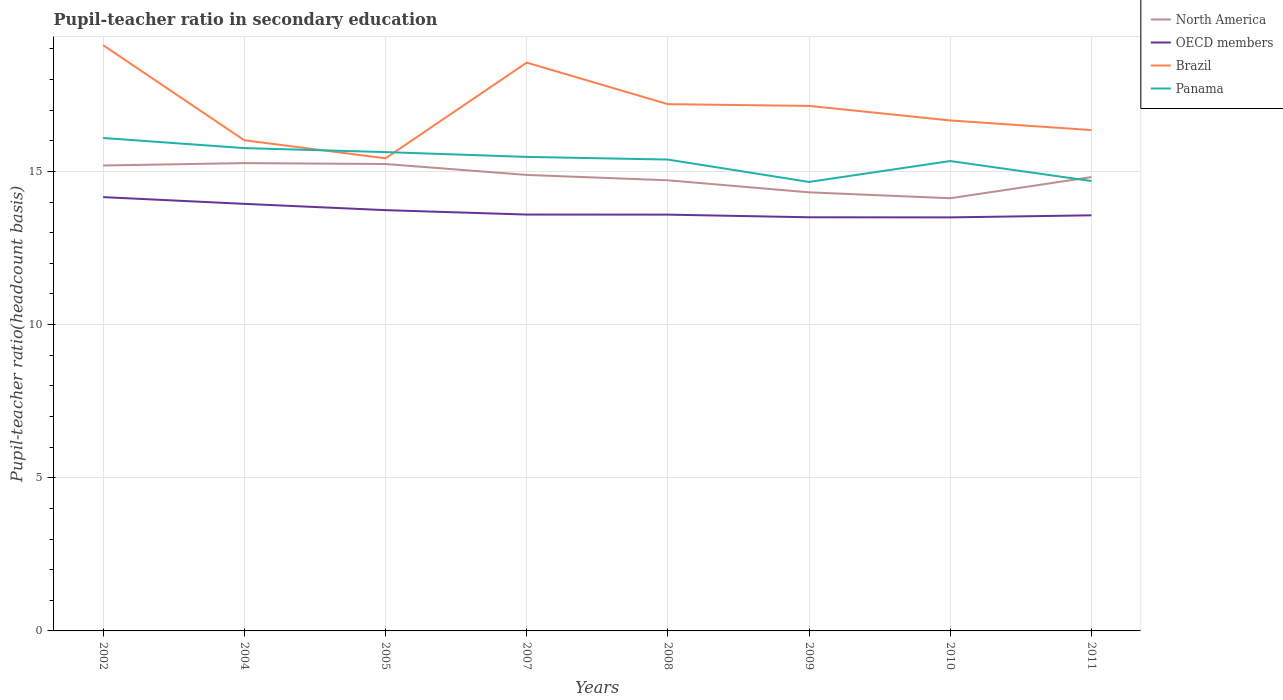How many different coloured lines are there?
Your response must be concise. 4. Across all years, what is the maximum pupil-teacher ratio in secondary education in Brazil?
Offer a terse response. 15.43. In which year was the pupil-teacher ratio in secondary education in OECD members maximum?
Your answer should be very brief. 2010. What is the total pupil-teacher ratio in secondary education in OECD members in the graph?
Your answer should be compact. -0.07. What is the difference between the highest and the second highest pupil-teacher ratio in secondary education in North America?
Ensure brevity in your answer.  1.15. What is the difference between the highest and the lowest pupil-teacher ratio in secondary education in Panama?
Keep it short and to the point. 5. Does the graph contain any zero values?
Offer a very short reply. No. Does the graph contain grids?
Keep it short and to the point. Yes. What is the title of the graph?
Your answer should be compact. Pupil-teacher ratio in secondary education. What is the label or title of the Y-axis?
Your answer should be compact. Pupil-teacher ratio(headcount basis). What is the Pupil-teacher ratio(headcount basis) of North America in 2002?
Offer a terse response. 15.19. What is the Pupil-teacher ratio(headcount basis) of OECD members in 2002?
Make the answer very short. 14.16. What is the Pupil-teacher ratio(headcount basis) in Brazil in 2002?
Offer a very short reply. 19.12. What is the Pupil-teacher ratio(headcount basis) in Panama in 2002?
Provide a short and direct response. 16.09. What is the Pupil-teacher ratio(headcount basis) in North America in 2004?
Provide a short and direct response. 15.27. What is the Pupil-teacher ratio(headcount basis) in OECD members in 2004?
Keep it short and to the point. 13.94. What is the Pupil-teacher ratio(headcount basis) in Brazil in 2004?
Your answer should be very brief. 16.02. What is the Pupil-teacher ratio(headcount basis) of Panama in 2004?
Provide a succinct answer. 15.76. What is the Pupil-teacher ratio(headcount basis) of North America in 2005?
Your answer should be very brief. 15.24. What is the Pupil-teacher ratio(headcount basis) in OECD members in 2005?
Your answer should be compact. 13.74. What is the Pupil-teacher ratio(headcount basis) in Brazil in 2005?
Make the answer very short. 15.43. What is the Pupil-teacher ratio(headcount basis) of Panama in 2005?
Make the answer very short. 15.63. What is the Pupil-teacher ratio(headcount basis) of North America in 2007?
Ensure brevity in your answer.  14.89. What is the Pupil-teacher ratio(headcount basis) of OECD members in 2007?
Your answer should be very brief. 13.59. What is the Pupil-teacher ratio(headcount basis) of Brazil in 2007?
Provide a short and direct response. 18.55. What is the Pupil-teacher ratio(headcount basis) of Panama in 2007?
Your response must be concise. 15.47. What is the Pupil-teacher ratio(headcount basis) in North America in 2008?
Ensure brevity in your answer.  14.71. What is the Pupil-teacher ratio(headcount basis) in OECD members in 2008?
Provide a short and direct response. 13.59. What is the Pupil-teacher ratio(headcount basis) of Brazil in 2008?
Provide a succinct answer. 17.2. What is the Pupil-teacher ratio(headcount basis) in Panama in 2008?
Provide a short and direct response. 15.39. What is the Pupil-teacher ratio(headcount basis) in North America in 2009?
Give a very brief answer. 14.32. What is the Pupil-teacher ratio(headcount basis) of OECD members in 2009?
Ensure brevity in your answer.  13.5. What is the Pupil-teacher ratio(headcount basis) of Brazil in 2009?
Your answer should be very brief. 17.14. What is the Pupil-teacher ratio(headcount basis) in Panama in 2009?
Offer a very short reply. 14.66. What is the Pupil-teacher ratio(headcount basis) of North America in 2010?
Ensure brevity in your answer.  14.12. What is the Pupil-teacher ratio(headcount basis) in OECD members in 2010?
Your answer should be compact. 13.5. What is the Pupil-teacher ratio(headcount basis) of Brazil in 2010?
Give a very brief answer. 16.66. What is the Pupil-teacher ratio(headcount basis) in Panama in 2010?
Make the answer very short. 15.34. What is the Pupil-teacher ratio(headcount basis) in North America in 2011?
Provide a succinct answer. 14.81. What is the Pupil-teacher ratio(headcount basis) in OECD members in 2011?
Provide a short and direct response. 13.57. What is the Pupil-teacher ratio(headcount basis) in Brazil in 2011?
Keep it short and to the point. 16.35. What is the Pupil-teacher ratio(headcount basis) in Panama in 2011?
Give a very brief answer. 14.69. Across all years, what is the maximum Pupil-teacher ratio(headcount basis) of North America?
Keep it short and to the point. 15.27. Across all years, what is the maximum Pupil-teacher ratio(headcount basis) of OECD members?
Offer a very short reply. 14.16. Across all years, what is the maximum Pupil-teacher ratio(headcount basis) in Brazil?
Your answer should be very brief. 19.12. Across all years, what is the maximum Pupil-teacher ratio(headcount basis) of Panama?
Your answer should be compact. 16.09. Across all years, what is the minimum Pupil-teacher ratio(headcount basis) of North America?
Make the answer very short. 14.12. Across all years, what is the minimum Pupil-teacher ratio(headcount basis) in OECD members?
Offer a terse response. 13.5. Across all years, what is the minimum Pupil-teacher ratio(headcount basis) of Brazil?
Offer a terse response. 15.43. Across all years, what is the minimum Pupil-teacher ratio(headcount basis) in Panama?
Make the answer very short. 14.66. What is the total Pupil-teacher ratio(headcount basis) of North America in the graph?
Make the answer very short. 118.56. What is the total Pupil-teacher ratio(headcount basis) in OECD members in the graph?
Ensure brevity in your answer.  109.59. What is the total Pupil-teacher ratio(headcount basis) in Brazil in the graph?
Provide a succinct answer. 136.46. What is the total Pupil-teacher ratio(headcount basis) in Panama in the graph?
Ensure brevity in your answer.  123.03. What is the difference between the Pupil-teacher ratio(headcount basis) of North America in 2002 and that in 2004?
Keep it short and to the point. -0.08. What is the difference between the Pupil-teacher ratio(headcount basis) of OECD members in 2002 and that in 2004?
Give a very brief answer. 0.22. What is the difference between the Pupil-teacher ratio(headcount basis) of Brazil in 2002 and that in 2004?
Provide a succinct answer. 3.1. What is the difference between the Pupil-teacher ratio(headcount basis) in Panama in 2002 and that in 2004?
Your answer should be very brief. 0.33. What is the difference between the Pupil-teacher ratio(headcount basis) of North America in 2002 and that in 2005?
Provide a short and direct response. -0.05. What is the difference between the Pupil-teacher ratio(headcount basis) in OECD members in 2002 and that in 2005?
Give a very brief answer. 0.42. What is the difference between the Pupil-teacher ratio(headcount basis) in Brazil in 2002 and that in 2005?
Keep it short and to the point. 3.69. What is the difference between the Pupil-teacher ratio(headcount basis) in Panama in 2002 and that in 2005?
Make the answer very short. 0.46. What is the difference between the Pupil-teacher ratio(headcount basis) in North America in 2002 and that in 2007?
Provide a succinct answer. 0.31. What is the difference between the Pupil-teacher ratio(headcount basis) in OECD members in 2002 and that in 2007?
Your answer should be very brief. 0.57. What is the difference between the Pupil-teacher ratio(headcount basis) of Brazil in 2002 and that in 2007?
Your answer should be compact. 0.57. What is the difference between the Pupil-teacher ratio(headcount basis) of Panama in 2002 and that in 2007?
Ensure brevity in your answer.  0.62. What is the difference between the Pupil-teacher ratio(headcount basis) of North America in 2002 and that in 2008?
Provide a succinct answer. 0.48. What is the difference between the Pupil-teacher ratio(headcount basis) in OECD members in 2002 and that in 2008?
Give a very brief answer. 0.57. What is the difference between the Pupil-teacher ratio(headcount basis) of Brazil in 2002 and that in 2008?
Your response must be concise. 1.93. What is the difference between the Pupil-teacher ratio(headcount basis) in Panama in 2002 and that in 2008?
Offer a very short reply. 0.7. What is the difference between the Pupil-teacher ratio(headcount basis) of North America in 2002 and that in 2009?
Offer a very short reply. 0.88. What is the difference between the Pupil-teacher ratio(headcount basis) in OECD members in 2002 and that in 2009?
Your answer should be compact. 0.66. What is the difference between the Pupil-teacher ratio(headcount basis) in Brazil in 2002 and that in 2009?
Provide a short and direct response. 1.98. What is the difference between the Pupil-teacher ratio(headcount basis) of Panama in 2002 and that in 2009?
Your response must be concise. 1.43. What is the difference between the Pupil-teacher ratio(headcount basis) of North America in 2002 and that in 2010?
Make the answer very short. 1.07. What is the difference between the Pupil-teacher ratio(headcount basis) in OECD members in 2002 and that in 2010?
Your answer should be compact. 0.66. What is the difference between the Pupil-teacher ratio(headcount basis) in Brazil in 2002 and that in 2010?
Keep it short and to the point. 2.46. What is the difference between the Pupil-teacher ratio(headcount basis) of Panama in 2002 and that in 2010?
Give a very brief answer. 0.75. What is the difference between the Pupil-teacher ratio(headcount basis) in North America in 2002 and that in 2011?
Provide a succinct answer. 0.38. What is the difference between the Pupil-teacher ratio(headcount basis) of OECD members in 2002 and that in 2011?
Offer a terse response. 0.59. What is the difference between the Pupil-teacher ratio(headcount basis) in Brazil in 2002 and that in 2011?
Give a very brief answer. 2.77. What is the difference between the Pupil-teacher ratio(headcount basis) of Panama in 2002 and that in 2011?
Keep it short and to the point. 1.4. What is the difference between the Pupil-teacher ratio(headcount basis) of North America in 2004 and that in 2005?
Your response must be concise. 0.03. What is the difference between the Pupil-teacher ratio(headcount basis) of OECD members in 2004 and that in 2005?
Provide a short and direct response. 0.21. What is the difference between the Pupil-teacher ratio(headcount basis) of Brazil in 2004 and that in 2005?
Offer a terse response. 0.59. What is the difference between the Pupil-teacher ratio(headcount basis) in Panama in 2004 and that in 2005?
Make the answer very short. 0.13. What is the difference between the Pupil-teacher ratio(headcount basis) of North America in 2004 and that in 2007?
Provide a short and direct response. 0.39. What is the difference between the Pupil-teacher ratio(headcount basis) of OECD members in 2004 and that in 2007?
Offer a very short reply. 0.35. What is the difference between the Pupil-teacher ratio(headcount basis) in Brazil in 2004 and that in 2007?
Your response must be concise. -2.53. What is the difference between the Pupil-teacher ratio(headcount basis) of Panama in 2004 and that in 2007?
Your answer should be very brief. 0.29. What is the difference between the Pupil-teacher ratio(headcount basis) in North America in 2004 and that in 2008?
Ensure brevity in your answer.  0.56. What is the difference between the Pupil-teacher ratio(headcount basis) in OECD members in 2004 and that in 2008?
Your response must be concise. 0.35. What is the difference between the Pupil-teacher ratio(headcount basis) in Brazil in 2004 and that in 2008?
Offer a terse response. -1.18. What is the difference between the Pupil-teacher ratio(headcount basis) of Panama in 2004 and that in 2008?
Offer a terse response. 0.37. What is the difference between the Pupil-teacher ratio(headcount basis) of North America in 2004 and that in 2009?
Ensure brevity in your answer.  0.95. What is the difference between the Pupil-teacher ratio(headcount basis) in OECD members in 2004 and that in 2009?
Provide a succinct answer. 0.44. What is the difference between the Pupil-teacher ratio(headcount basis) in Brazil in 2004 and that in 2009?
Keep it short and to the point. -1.12. What is the difference between the Pupil-teacher ratio(headcount basis) in Panama in 2004 and that in 2009?
Provide a short and direct response. 1.1. What is the difference between the Pupil-teacher ratio(headcount basis) in North America in 2004 and that in 2010?
Your answer should be very brief. 1.15. What is the difference between the Pupil-teacher ratio(headcount basis) of OECD members in 2004 and that in 2010?
Provide a succinct answer. 0.44. What is the difference between the Pupil-teacher ratio(headcount basis) in Brazil in 2004 and that in 2010?
Offer a very short reply. -0.65. What is the difference between the Pupil-teacher ratio(headcount basis) in Panama in 2004 and that in 2010?
Offer a very short reply. 0.42. What is the difference between the Pupil-teacher ratio(headcount basis) in North America in 2004 and that in 2011?
Provide a short and direct response. 0.46. What is the difference between the Pupil-teacher ratio(headcount basis) in OECD members in 2004 and that in 2011?
Keep it short and to the point. 0.37. What is the difference between the Pupil-teacher ratio(headcount basis) of Brazil in 2004 and that in 2011?
Provide a succinct answer. -0.33. What is the difference between the Pupil-teacher ratio(headcount basis) in Panama in 2004 and that in 2011?
Ensure brevity in your answer.  1.07. What is the difference between the Pupil-teacher ratio(headcount basis) in North America in 2005 and that in 2007?
Offer a very short reply. 0.36. What is the difference between the Pupil-teacher ratio(headcount basis) in OECD members in 2005 and that in 2007?
Offer a terse response. 0.14. What is the difference between the Pupil-teacher ratio(headcount basis) of Brazil in 2005 and that in 2007?
Your response must be concise. -3.12. What is the difference between the Pupil-teacher ratio(headcount basis) in Panama in 2005 and that in 2007?
Provide a short and direct response. 0.16. What is the difference between the Pupil-teacher ratio(headcount basis) in North America in 2005 and that in 2008?
Give a very brief answer. 0.53. What is the difference between the Pupil-teacher ratio(headcount basis) of OECD members in 2005 and that in 2008?
Your answer should be compact. 0.15. What is the difference between the Pupil-teacher ratio(headcount basis) in Brazil in 2005 and that in 2008?
Your answer should be very brief. -1.77. What is the difference between the Pupil-teacher ratio(headcount basis) of Panama in 2005 and that in 2008?
Offer a very short reply. 0.24. What is the difference between the Pupil-teacher ratio(headcount basis) in North America in 2005 and that in 2009?
Your answer should be compact. 0.92. What is the difference between the Pupil-teacher ratio(headcount basis) in OECD members in 2005 and that in 2009?
Your response must be concise. 0.23. What is the difference between the Pupil-teacher ratio(headcount basis) in Brazil in 2005 and that in 2009?
Ensure brevity in your answer.  -1.71. What is the difference between the Pupil-teacher ratio(headcount basis) in Panama in 2005 and that in 2009?
Your answer should be very brief. 0.97. What is the difference between the Pupil-teacher ratio(headcount basis) of North America in 2005 and that in 2010?
Offer a terse response. 1.12. What is the difference between the Pupil-teacher ratio(headcount basis) of OECD members in 2005 and that in 2010?
Keep it short and to the point. 0.24. What is the difference between the Pupil-teacher ratio(headcount basis) of Brazil in 2005 and that in 2010?
Provide a short and direct response. -1.24. What is the difference between the Pupil-teacher ratio(headcount basis) in Panama in 2005 and that in 2010?
Make the answer very short. 0.29. What is the difference between the Pupil-teacher ratio(headcount basis) of North America in 2005 and that in 2011?
Make the answer very short. 0.43. What is the difference between the Pupil-teacher ratio(headcount basis) of OECD members in 2005 and that in 2011?
Your answer should be very brief. 0.17. What is the difference between the Pupil-teacher ratio(headcount basis) of Brazil in 2005 and that in 2011?
Offer a very short reply. -0.92. What is the difference between the Pupil-teacher ratio(headcount basis) in Panama in 2005 and that in 2011?
Your answer should be very brief. 0.94. What is the difference between the Pupil-teacher ratio(headcount basis) in North America in 2007 and that in 2008?
Provide a short and direct response. 0.18. What is the difference between the Pupil-teacher ratio(headcount basis) in OECD members in 2007 and that in 2008?
Keep it short and to the point. 0. What is the difference between the Pupil-teacher ratio(headcount basis) in Brazil in 2007 and that in 2008?
Ensure brevity in your answer.  1.36. What is the difference between the Pupil-teacher ratio(headcount basis) of Panama in 2007 and that in 2008?
Offer a terse response. 0.09. What is the difference between the Pupil-teacher ratio(headcount basis) in North America in 2007 and that in 2009?
Your answer should be compact. 0.57. What is the difference between the Pupil-teacher ratio(headcount basis) in OECD members in 2007 and that in 2009?
Provide a succinct answer. 0.09. What is the difference between the Pupil-teacher ratio(headcount basis) of Brazil in 2007 and that in 2009?
Provide a short and direct response. 1.41. What is the difference between the Pupil-teacher ratio(headcount basis) in Panama in 2007 and that in 2009?
Your response must be concise. 0.82. What is the difference between the Pupil-teacher ratio(headcount basis) in North America in 2007 and that in 2010?
Provide a short and direct response. 0.76. What is the difference between the Pupil-teacher ratio(headcount basis) in OECD members in 2007 and that in 2010?
Keep it short and to the point. 0.09. What is the difference between the Pupil-teacher ratio(headcount basis) in Brazil in 2007 and that in 2010?
Give a very brief answer. 1.89. What is the difference between the Pupil-teacher ratio(headcount basis) of Panama in 2007 and that in 2010?
Your answer should be compact. 0.14. What is the difference between the Pupil-teacher ratio(headcount basis) of North America in 2007 and that in 2011?
Keep it short and to the point. 0.07. What is the difference between the Pupil-teacher ratio(headcount basis) in OECD members in 2007 and that in 2011?
Offer a terse response. 0.02. What is the difference between the Pupil-teacher ratio(headcount basis) in Brazil in 2007 and that in 2011?
Provide a short and direct response. 2.2. What is the difference between the Pupil-teacher ratio(headcount basis) of Panama in 2007 and that in 2011?
Offer a very short reply. 0.79. What is the difference between the Pupil-teacher ratio(headcount basis) of North America in 2008 and that in 2009?
Your answer should be very brief. 0.39. What is the difference between the Pupil-teacher ratio(headcount basis) of OECD members in 2008 and that in 2009?
Your answer should be very brief. 0.09. What is the difference between the Pupil-teacher ratio(headcount basis) in Brazil in 2008 and that in 2009?
Your answer should be very brief. 0.06. What is the difference between the Pupil-teacher ratio(headcount basis) of Panama in 2008 and that in 2009?
Your answer should be very brief. 0.73. What is the difference between the Pupil-teacher ratio(headcount basis) of North America in 2008 and that in 2010?
Provide a succinct answer. 0.59. What is the difference between the Pupil-teacher ratio(headcount basis) of OECD members in 2008 and that in 2010?
Provide a short and direct response. 0.09. What is the difference between the Pupil-teacher ratio(headcount basis) of Brazil in 2008 and that in 2010?
Your answer should be very brief. 0.53. What is the difference between the Pupil-teacher ratio(headcount basis) of Panama in 2008 and that in 2010?
Your response must be concise. 0.05. What is the difference between the Pupil-teacher ratio(headcount basis) in North America in 2008 and that in 2011?
Your answer should be very brief. -0.1. What is the difference between the Pupil-teacher ratio(headcount basis) in OECD members in 2008 and that in 2011?
Keep it short and to the point. 0.02. What is the difference between the Pupil-teacher ratio(headcount basis) of Brazil in 2008 and that in 2011?
Make the answer very short. 0.85. What is the difference between the Pupil-teacher ratio(headcount basis) in Panama in 2008 and that in 2011?
Your response must be concise. 0.7. What is the difference between the Pupil-teacher ratio(headcount basis) of North America in 2009 and that in 2010?
Your answer should be very brief. 0.19. What is the difference between the Pupil-teacher ratio(headcount basis) of OECD members in 2009 and that in 2010?
Your response must be concise. 0. What is the difference between the Pupil-teacher ratio(headcount basis) in Brazil in 2009 and that in 2010?
Offer a very short reply. 0.47. What is the difference between the Pupil-teacher ratio(headcount basis) in Panama in 2009 and that in 2010?
Provide a succinct answer. -0.68. What is the difference between the Pupil-teacher ratio(headcount basis) of North America in 2009 and that in 2011?
Make the answer very short. -0.5. What is the difference between the Pupil-teacher ratio(headcount basis) of OECD members in 2009 and that in 2011?
Provide a short and direct response. -0.06. What is the difference between the Pupil-teacher ratio(headcount basis) in Brazil in 2009 and that in 2011?
Make the answer very short. 0.79. What is the difference between the Pupil-teacher ratio(headcount basis) of Panama in 2009 and that in 2011?
Your answer should be very brief. -0.03. What is the difference between the Pupil-teacher ratio(headcount basis) in North America in 2010 and that in 2011?
Keep it short and to the point. -0.69. What is the difference between the Pupil-teacher ratio(headcount basis) of OECD members in 2010 and that in 2011?
Keep it short and to the point. -0.07. What is the difference between the Pupil-teacher ratio(headcount basis) of Brazil in 2010 and that in 2011?
Offer a terse response. 0.31. What is the difference between the Pupil-teacher ratio(headcount basis) of Panama in 2010 and that in 2011?
Offer a very short reply. 0.65. What is the difference between the Pupil-teacher ratio(headcount basis) in North America in 2002 and the Pupil-teacher ratio(headcount basis) in OECD members in 2004?
Provide a succinct answer. 1.25. What is the difference between the Pupil-teacher ratio(headcount basis) of North America in 2002 and the Pupil-teacher ratio(headcount basis) of Brazil in 2004?
Your answer should be compact. -0.82. What is the difference between the Pupil-teacher ratio(headcount basis) in North America in 2002 and the Pupil-teacher ratio(headcount basis) in Panama in 2004?
Your answer should be very brief. -0.57. What is the difference between the Pupil-teacher ratio(headcount basis) of OECD members in 2002 and the Pupil-teacher ratio(headcount basis) of Brazil in 2004?
Keep it short and to the point. -1.86. What is the difference between the Pupil-teacher ratio(headcount basis) of OECD members in 2002 and the Pupil-teacher ratio(headcount basis) of Panama in 2004?
Offer a terse response. -1.6. What is the difference between the Pupil-teacher ratio(headcount basis) of Brazil in 2002 and the Pupil-teacher ratio(headcount basis) of Panama in 2004?
Your answer should be very brief. 3.36. What is the difference between the Pupil-teacher ratio(headcount basis) in North America in 2002 and the Pupil-teacher ratio(headcount basis) in OECD members in 2005?
Your answer should be compact. 1.46. What is the difference between the Pupil-teacher ratio(headcount basis) of North America in 2002 and the Pupil-teacher ratio(headcount basis) of Brazil in 2005?
Give a very brief answer. -0.23. What is the difference between the Pupil-teacher ratio(headcount basis) of North America in 2002 and the Pupil-teacher ratio(headcount basis) of Panama in 2005?
Your answer should be very brief. -0.44. What is the difference between the Pupil-teacher ratio(headcount basis) in OECD members in 2002 and the Pupil-teacher ratio(headcount basis) in Brazil in 2005?
Keep it short and to the point. -1.27. What is the difference between the Pupil-teacher ratio(headcount basis) in OECD members in 2002 and the Pupil-teacher ratio(headcount basis) in Panama in 2005?
Your response must be concise. -1.47. What is the difference between the Pupil-teacher ratio(headcount basis) in Brazil in 2002 and the Pupil-teacher ratio(headcount basis) in Panama in 2005?
Offer a very short reply. 3.49. What is the difference between the Pupil-teacher ratio(headcount basis) of North America in 2002 and the Pupil-teacher ratio(headcount basis) of OECD members in 2007?
Your answer should be very brief. 1.6. What is the difference between the Pupil-teacher ratio(headcount basis) in North America in 2002 and the Pupil-teacher ratio(headcount basis) in Brazil in 2007?
Keep it short and to the point. -3.36. What is the difference between the Pupil-teacher ratio(headcount basis) of North America in 2002 and the Pupil-teacher ratio(headcount basis) of Panama in 2007?
Make the answer very short. -0.28. What is the difference between the Pupil-teacher ratio(headcount basis) of OECD members in 2002 and the Pupil-teacher ratio(headcount basis) of Brazil in 2007?
Keep it short and to the point. -4.39. What is the difference between the Pupil-teacher ratio(headcount basis) in OECD members in 2002 and the Pupil-teacher ratio(headcount basis) in Panama in 2007?
Give a very brief answer. -1.31. What is the difference between the Pupil-teacher ratio(headcount basis) in Brazil in 2002 and the Pupil-teacher ratio(headcount basis) in Panama in 2007?
Make the answer very short. 3.65. What is the difference between the Pupil-teacher ratio(headcount basis) of North America in 2002 and the Pupil-teacher ratio(headcount basis) of OECD members in 2008?
Offer a terse response. 1.6. What is the difference between the Pupil-teacher ratio(headcount basis) of North America in 2002 and the Pupil-teacher ratio(headcount basis) of Brazil in 2008?
Provide a succinct answer. -2. What is the difference between the Pupil-teacher ratio(headcount basis) of North America in 2002 and the Pupil-teacher ratio(headcount basis) of Panama in 2008?
Give a very brief answer. -0.19. What is the difference between the Pupil-teacher ratio(headcount basis) in OECD members in 2002 and the Pupil-teacher ratio(headcount basis) in Brazil in 2008?
Your response must be concise. -3.03. What is the difference between the Pupil-teacher ratio(headcount basis) of OECD members in 2002 and the Pupil-teacher ratio(headcount basis) of Panama in 2008?
Provide a short and direct response. -1.23. What is the difference between the Pupil-teacher ratio(headcount basis) of Brazil in 2002 and the Pupil-teacher ratio(headcount basis) of Panama in 2008?
Ensure brevity in your answer.  3.73. What is the difference between the Pupil-teacher ratio(headcount basis) in North America in 2002 and the Pupil-teacher ratio(headcount basis) in OECD members in 2009?
Provide a succinct answer. 1.69. What is the difference between the Pupil-teacher ratio(headcount basis) in North America in 2002 and the Pupil-teacher ratio(headcount basis) in Brazil in 2009?
Your answer should be compact. -1.95. What is the difference between the Pupil-teacher ratio(headcount basis) of North America in 2002 and the Pupil-teacher ratio(headcount basis) of Panama in 2009?
Provide a succinct answer. 0.54. What is the difference between the Pupil-teacher ratio(headcount basis) of OECD members in 2002 and the Pupil-teacher ratio(headcount basis) of Brazil in 2009?
Offer a very short reply. -2.98. What is the difference between the Pupil-teacher ratio(headcount basis) in OECD members in 2002 and the Pupil-teacher ratio(headcount basis) in Panama in 2009?
Make the answer very short. -0.5. What is the difference between the Pupil-teacher ratio(headcount basis) in Brazil in 2002 and the Pupil-teacher ratio(headcount basis) in Panama in 2009?
Offer a terse response. 4.46. What is the difference between the Pupil-teacher ratio(headcount basis) of North America in 2002 and the Pupil-teacher ratio(headcount basis) of OECD members in 2010?
Offer a very short reply. 1.69. What is the difference between the Pupil-teacher ratio(headcount basis) in North America in 2002 and the Pupil-teacher ratio(headcount basis) in Brazil in 2010?
Ensure brevity in your answer.  -1.47. What is the difference between the Pupil-teacher ratio(headcount basis) in North America in 2002 and the Pupil-teacher ratio(headcount basis) in Panama in 2010?
Keep it short and to the point. -0.15. What is the difference between the Pupil-teacher ratio(headcount basis) of OECD members in 2002 and the Pupil-teacher ratio(headcount basis) of Brazil in 2010?
Provide a short and direct response. -2.5. What is the difference between the Pupil-teacher ratio(headcount basis) of OECD members in 2002 and the Pupil-teacher ratio(headcount basis) of Panama in 2010?
Your answer should be compact. -1.18. What is the difference between the Pupil-teacher ratio(headcount basis) in Brazil in 2002 and the Pupil-teacher ratio(headcount basis) in Panama in 2010?
Provide a succinct answer. 3.78. What is the difference between the Pupil-teacher ratio(headcount basis) of North America in 2002 and the Pupil-teacher ratio(headcount basis) of OECD members in 2011?
Your response must be concise. 1.63. What is the difference between the Pupil-teacher ratio(headcount basis) of North America in 2002 and the Pupil-teacher ratio(headcount basis) of Brazil in 2011?
Keep it short and to the point. -1.16. What is the difference between the Pupil-teacher ratio(headcount basis) of North America in 2002 and the Pupil-teacher ratio(headcount basis) of Panama in 2011?
Offer a very short reply. 0.51. What is the difference between the Pupil-teacher ratio(headcount basis) in OECD members in 2002 and the Pupil-teacher ratio(headcount basis) in Brazil in 2011?
Provide a short and direct response. -2.19. What is the difference between the Pupil-teacher ratio(headcount basis) of OECD members in 2002 and the Pupil-teacher ratio(headcount basis) of Panama in 2011?
Keep it short and to the point. -0.53. What is the difference between the Pupil-teacher ratio(headcount basis) of Brazil in 2002 and the Pupil-teacher ratio(headcount basis) of Panama in 2011?
Make the answer very short. 4.43. What is the difference between the Pupil-teacher ratio(headcount basis) in North America in 2004 and the Pupil-teacher ratio(headcount basis) in OECD members in 2005?
Offer a very short reply. 1.54. What is the difference between the Pupil-teacher ratio(headcount basis) in North America in 2004 and the Pupil-teacher ratio(headcount basis) in Brazil in 2005?
Your answer should be compact. -0.16. What is the difference between the Pupil-teacher ratio(headcount basis) of North America in 2004 and the Pupil-teacher ratio(headcount basis) of Panama in 2005?
Keep it short and to the point. -0.36. What is the difference between the Pupil-teacher ratio(headcount basis) in OECD members in 2004 and the Pupil-teacher ratio(headcount basis) in Brazil in 2005?
Make the answer very short. -1.49. What is the difference between the Pupil-teacher ratio(headcount basis) of OECD members in 2004 and the Pupil-teacher ratio(headcount basis) of Panama in 2005?
Keep it short and to the point. -1.69. What is the difference between the Pupil-teacher ratio(headcount basis) of Brazil in 2004 and the Pupil-teacher ratio(headcount basis) of Panama in 2005?
Your answer should be compact. 0.39. What is the difference between the Pupil-teacher ratio(headcount basis) of North America in 2004 and the Pupil-teacher ratio(headcount basis) of OECD members in 2007?
Provide a short and direct response. 1.68. What is the difference between the Pupil-teacher ratio(headcount basis) of North America in 2004 and the Pupil-teacher ratio(headcount basis) of Brazil in 2007?
Offer a very short reply. -3.28. What is the difference between the Pupil-teacher ratio(headcount basis) of North America in 2004 and the Pupil-teacher ratio(headcount basis) of Panama in 2007?
Ensure brevity in your answer.  -0.2. What is the difference between the Pupil-teacher ratio(headcount basis) of OECD members in 2004 and the Pupil-teacher ratio(headcount basis) of Brazil in 2007?
Offer a terse response. -4.61. What is the difference between the Pupil-teacher ratio(headcount basis) of OECD members in 2004 and the Pupil-teacher ratio(headcount basis) of Panama in 2007?
Your answer should be compact. -1.53. What is the difference between the Pupil-teacher ratio(headcount basis) in Brazil in 2004 and the Pupil-teacher ratio(headcount basis) in Panama in 2007?
Your response must be concise. 0.54. What is the difference between the Pupil-teacher ratio(headcount basis) of North America in 2004 and the Pupil-teacher ratio(headcount basis) of OECD members in 2008?
Keep it short and to the point. 1.68. What is the difference between the Pupil-teacher ratio(headcount basis) of North America in 2004 and the Pupil-teacher ratio(headcount basis) of Brazil in 2008?
Your answer should be very brief. -1.92. What is the difference between the Pupil-teacher ratio(headcount basis) of North America in 2004 and the Pupil-teacher ratio(headcount basis) of Panama in 2008?
Your response must be concise. -0.11. What is the difference between the Pupil-teacher ratio(headcount basis) of OECD members in 2004 and the Pupil-teacher ratio(headcount basis) of Brazil in 2008?
Offer a terse response. -3.25. What is the difference between the Pupil-teacher ratio(headcount basis) of OECD members in 2004 and the Pupil-teacher ratio(headcount basis) of Panama in 2008?
Your answer should be very brief. -1.45. What is the difference between the Pupil-teacher ratio(headcount basis) of Brazil in 2004 and the Pupil-teacher ratio(headcount basis) of Panama in 2008?
Ensure brevity in your answer.  0.63. What is the difference between the Pupil-teacher ratio(headcount basis) in North America in 2004 and the Pupil-teacher ratio(headcount basis) in OECD members in 2009?
Your response must be concise. 1.77. What is the difference between the Pupil-teacher ratio(headcount basis) in North America in 2004 and the Pupil-teacher ratio(headcount basis) in Brazil in 2009?
Your answer should be compact. -1.87. What is the difference between the Pupil-teacher ratio(headcount basis) of North America in 2004 and the Pupil-teacher ratio(headcount basis) of Panama in 2009?
Your response must be concise. 0.62. What is the difference between the Pupil-teacher ratio(headcount basis) of OECD members in 2004 and the Pupil-teacher ratio(headcount basis) of Brazil in 2009?
Your answer should be compact. -3.2. What is the difference between the Pupil-teacher ratio(headcount basis) of OECD members in 2004 and the Pupil-teacher ratio(headcount basis) of Panama in 2009?
Ensure brevity in your answer.  -0.72. What is the difference between the Pupil-teacher ratio(headcount basis) of Brazil in 2004 and the Pupil-teacher ratio(headcount basis) of Panama in 2009?
Keep it short and to the point. 1.36. What is the difference between the Pupil-teacher ratio(headcount basis) of North America in 2004 and the Pupil-teacher ratio(headcount basis) of OECD members in 2010?
Provide a short and direct response. 1.77. What is the difference between the Pupil-teacher ratio(headcount basis) of North America in 2004 and the Pupil-teacher ratio(headcount basis) of Brazil in 2010?
Your response must be concise. -1.39. What is the difference between the Pupil-teacher ratio(headcount basis) of North America in 2004 and the Pupil-teacher ratio(headcount basis) of Panama in 2010?
Offer a terse response. -0.07. What is the difference between the Pupil-teacher ratio(headcount basis) in OECD members in 2004 and the Pupil-teacher ratio(headcount basis) in Brazil in 2010?
Ensure brevity in your answer.  -2.72. What is the difference between the Pupil-teacher ratio(headcount basis) of OECD members in 2004 and the Pupil-teacher ratio(headcount basis) of Panama in 2010?
Make the answer very short. -1.4. What is the difference between the Pupil-teacher ratio(headcount basis) of Brazil in 2004 and the Pupil-teacher ratio(headcount basis) of Panama in 2010?
Your answer should be very brief. 0.68. What is the difference between the Pupil-teacher ratio(headcount basis) of North America in 2004 and the Pupil-teacher ratio(headcount basis) of OECD members in 2011?
Your answer should be very brief. 1.7. What is the difference between the Pupil-teacher ratio(headcount basis) in North America in 2004 and the Pupil-teacher ratio(headcount basis) in Brazil in 2011?
Offer a terse response. -1.08. What is the difference between the Pupil-teacher ratio(headcount basis) in North America in 2004 and the Pupil-teacher ratio(headcount basis) in Panama in 2011?
Your answer should be compact. 0.59. What is the difference between the Pupil-teacher ratio(headcount basis) in OECD members in 2004 and the Pupil-teacher ratio(headcount basis) in Brazil in 2011?
Offer a very short reply. -2.41. What is the difference between the Pupil-teacher ratio(headcount basis) in OECD members in 2004 and the Pupil-teacher ratio(headcount basis) in Panama in 2011?
Make the answer very short. -0.75. What is the difference between the Pupil-teacher ratio(headcount basis) in Brazil in 2004 and the Pupil-teacher ratio(headcount basis) in Panama in 2011?
Your response must be concise. 1.33. What is the difference between the Pupil-teacher ratio(headcount basis) in North America in 2005 and the Pupil-teacher ratio(headcount basis) in OECD members in 2007?
Keep it short and to the point. 1.65. What is the difference between the Pupil-teacher ratio(headcount basis) of North America in 2005 and the Pupil-teacher ratio(headcount basis) of Brazil in 2007?
Offer a very short reply. -3.31. What is the difference between the Pupil-teacher ratio(headcount basis) of North America in 2005 and the Pupil-teacher ratio(headcount basis) of Panama in 2007?
Provide a short and direct response. -0.23. What is the difference between the Pupil-teacher ratio(headcount basis) in OECD members in 2005 and the Pupil-teacher ratio(headcount basis) in Brazil in 2007?
Ensure brevity in your answer.  -4.82. What is the difference between the Pupil-teacher ratio(headcount basis) of OECD members in 2005 and the Pupil-teacher ratio(headcount basis) of Panama in 2007?
Give a very brief answer. -1.74. What is the difference between the Pupil-teacher ratio(headcount basis) of Brazil in 2005 and the Pupil-teacher ratio(headcount basis) of Panama in 2007?
Your answer should be very brief. -0.05. What is the difference between the Pupil-teacher ratio(headcount basis) of North America in 2005 and the Pupil-teacher ratio(headcount basis) of OECD members in 2008?
Make the answer very short. 1.65. What is the difference between the Pupil-teacher ratio(headcount basis) in North America in 2005 and the Pupil-teacher ratio(headcount basis) in Brazil in 2008?
Offer a very short reply. -1.95. What is the difference between the Pupil-teacher ratio(headcount basis) in North America in 2005 and the Pupil-teacher ratio(headcount basis) in Panama in 2008?
Provide a short and direct response. -0.14. What is the difference between the Pupil-teacher ratio(headcount basis) of OECD members in 2005 and the Pupil-teacher ratio(headcount basis) of Brazil in 2008?
Give a very brief answer. -3.46. What is the difference between the Pupil-teacher ratio(headcount basis) of OECD members in 2005 and the Pupil-teacher ratio(headcount basis) of Panama in 2008?
Give a very brief answer. -1.65. What is the difference between the Pupil-teacher ratio(headcount basis) in Brazil in 2005 and the Pupil-teacher ratio(headcount basis) in Panama in 2008?
Keep it short and to the point. 0.04. What is the difference between the Pupil-teacher ratio(headcount basis) in North America in 2005 and the Pupil-teacher ratio(headcount basis) in OECD members in 2009?
Provide a succinct answer. 1.74. What is the difference between the Pupil-teacher ratio(headcount basis) of North America in 2005 and the Pupil-teacher ratio(headcount basis) of Brazil in 2009?
Your response must be concise. -1.9. What is the difference between the Pupil-teacher ratio(headcount basis) in North America in 2005 and the Pupil-teacher ratio(headcount basis) in Panama in 2009?
Your answer should be very brief. 0.59. What is the difference between the Pupil-teacher ratio(headcount basis) of OECD members in 2005 and the Pupil-teacher ratio(headcount basis) of Brazil in 2009?
Your response must be concise. -3.4. What is the difference between the Pupil-teacher ratio(headcount basis) in OECD members in 2005 and the Pupil-teacher ratio(headcount basis) in Panama in 2009?
Your response must be concise. -0.92. What is the difference between the Pupil-teacher ratio(headcount basis) of Brazil in 2005 and the Pupil-teacher ratio(headcount basis) of Panama in 2009?
Give a very brief answer. 0.77. What is the difference between the Pupil-teacher ratio(headcount basis) of North America in 2005 and the Pupil-teacher ratio(headcount basis) of OECD members in 2010?
Offer a terse response. 1.74. What is the difference between the Pupil-teacher ratio(headcount basis) in North America in 2005 and the Pupil-teacher ratio(headcount basis) in Brazil in 2010?
Your response must be concise. -1.42. What is the difference between the Pupil-teacher ratio(headcount basis) in North America in 2005 and the Pupil-teacher ratio(headcount basis) in Panama in 2010?
Give a very brief answer. -0.1. What is the difference between the Pupil-teacher ratio(headcount basis) of OECD members in 2005 and the Pupil-teacher ratio(headcount basis) of Brazil in 2010?
Keep it short and to the point. -2.93. What is the difference between the Pupil-teacher ratio(headcount basis) of OECD members in 2005 and the Pupil-teacher ratio(headcount basis) of Panama in 2010?
Keep it short and to the point. -1.6. What is the difference between the Pupil-teacher ratio(headcount basis) of Brazil in 2005 and the Pupil-teacher ratio(headcount basis) of Panama in 2010?
Make the answer very short. 0.09. What is the difference between the Pupil-teacher ratio(headcount basis) in North America in 2005 and the Pupil-teacher ratio(headcount basis) in OECD members in 2011?
Provide a short and direct response. 1.67. What is the difference between the Pupil-teacher ratio(headcount basis) of North America in 2005 and the Pupil-teacher ratio(headcount basis) of Brazil in 2011?
Your answer should be compact. -1.11. What is the difference between the Pupil-teacher ratio(headcount basis) of North America in 2005 and the Pupil-teacher ratio(headcount basis) of Panama in 2011?
Your response must be concise. 0.56. What is the difference between the Pupil-teacher ratio(headcount basis) in OECD members in 2005 and the Pupil-teacher ratio(headcount basis) in Brazil in 2011?
Make the answer very short. -2.61. What is the difference between the Pupil-teacher ratio(headcount basis) of OECD members in 2005 and the Pupil-teacher ratio(headcount basis) of Panama in 2011?
Give a very brief answer. -0.95. What is the difference between the Pupil-teacher ratio(headcount basis) of Brazil in 2005 and the Pupil-teacher ratio(headcount basis) of Panama in 2011?
Ensure brevity in your answer.  0.74. What is the difference between the Pupil-teacher ratio(headcount basis) in North America in 2007 and the Pupil-teacher ratio(headcount basis) in OECD members in 2008?
Your response must be concise. 1.3. What is the difference between the Pupil-teacher ratio(headcount basis) of North America in 2007 and the Pupil-teacher ratio(headcount basis) of Brazil in 2008?
Provide a short and direct response. -2.31. What is the difference between the Pupil-teacher ratio(headcount basis) of North America in 2007 and the Pupil-teacher ratio(headcount basis) of Panama in 2008?
Provide a short and direct response. -0.5. What is the difference between the Pupil-teacher ratio(headcount basis) of OECD members in 2007 and the Pupil-teacher ratio(headcount basis) of Brazil in 2008?
Ensure brevity in your answer.  -3.6. What is the difference between the Pupil-teacher ratio(headcount basis) in OECD members in 2007 and the Pupil-teacher ratio(headcount basis) in Panama in 2008?
Give a very brief answer. -1.79. What is the difference between the Pupil-teacher ratio(headcount basis) in Brazil in 2007 and the Pupil-teacher ratio(headcount basis) in Panama in 2008?
Give a very brief answer. 3.16. What is the difference between the Pupil-teacher ratio(headcount basis) of North America in 2007 and the Pupil-teacher ratio(headcount basis) of OECD members in 2009?
Keep it short and to the point. 1.38. What is the difference between the Pupil-teacher ratio(headcount basis) in North America in 2007 and the Pupil-teacher ratio(headcount basis) in Brazil in 2009?
Make the answer very short. -2.25. What is the difference between the Pupil-teacher ratio(headcount basis) of North America in 2007 and the Pupil-teacher ratio(headcount basis) of Panama in 2009?
Your answer should be very brief. 0.23. What is the difference between the Pupil-teacher ratio(headcount basis) in OECD members in 2007 and the Pupil-teacher ratio(headcount basis) in Brazil in 2009?
Provide a short and direct response. -3.55. What is the difference between the Pupil-teacher ratio(headcount basis) in OECD members in 2007 and the Pupil-teacher ratio(headcount basis) in Panama in 2009?
Provide a short and direct response. -1.06. What is the difference between the Pupil-teacher ratio(headcount basis) of Brazil in 2007 and the Pupil-teacher ratio(headcount basis) of Panama in 2009?
Provide a succinct answer. 3.9. What is the difference between the Pupil-teacher ratio(headcount basis) in North America in 2007 and the Pupil-teacher ratio(headcount basis) in OECD members in 2010?
Keep it short and to the point. 1.39. What is the difference between the Pupil-teacher ratio(headcount basis) in North America in 2007 and the Pupil-teacher ratio(headcount basis) in Brazil in 2010?
Provide a short and direct response. -1.78. What is the difference between the Pupil-teacher ratio(headcount basis) of North America in 2007 and the Pupil-teacher ratio(headcount basis) of Panama in 2010?
Your answer should be compact. -0.45. What is the difference between the Pupil-teacher ratio(headcount basis) of OECD members in 2007 and the Pupil-teacher ratio(headcount basis) of Brazil in 2010?
Offer a very short reply. -3.07. What is the difference between the Pupil-teacher ratio(headcount basis) of OECD members in 2007 and the Pupil-teacher ratio(headcount basis) of Panama in 2010?
Your response must be concise. -1.75. What is the difference between the Pupil-teacher ratio(headcount basis) of Brazil in 2007 and the Pupil-teacher ratio(headcount basis) of Panama in 2010?
Your answer should be very brief. 3.21. What is the difference between the Pupil-teacher ratio(headcount basis) in North America in 2007 and the Pupil-teacher ratio(headcount basis) in OECD members in 2011?
Your response must be concise. 1.32. What is the difference between the Pupil-teacher ratio(headcount basis) of North America in 2007 and the Pupil-teacher ratio(headcount basis) of Brazil in 2011?
Your answer should be very brief. -1.46. What is the difference between the Pupil-teacher ratio(headcount basis) of North America in 2007 and the Pupil-teacher ratio(headcount basis) of Panama in 2011?
Provide a short and direct response. 0.2. What is the difference between the Pupil-teacher ratio(headcount basis) in OECD members in 2007 and the Pupil-teacher ratio(headcount basis) in Brazil in 2011?
Give a very brief answer. -2.76. What is the difference between the Pupil-teacher ratio(headcount basis) in OECD members in 2007 and the Pupil-teacher ratio(headcount basis) in Panama in 2011?
Your answer should be compact. -1.09. What is the difference between the Pupil-teacher ratio(headcount basis) in Brazil in 2007 and the Pupil-teacher ratio(headcount basis) in Panama in 2011?
Make the answer very short. 3.87. What is the difference between the Pupil-teacher ratio(headcount basis) of North America in 2008 and the Pupil-teacher ratio(headcount basis) of OECD members in 2009?
Make the answer very short. 1.21. What is the difference between the Pupil-teacher ratio(headcount basis) in North America in 2008 and the Pupil-teacher ratio(headcount basis) in Brazil in 2009?
Make the answer very short. -2.43. What is the difference between the Pupil-teacher ratio(headcount basis) in North America in 2008 and the Pupil-teacher ratio(headcount basis) in Panama in 2009?
Your response must be concise. 0.05. What is the difference between the Pupil-teacher ratio(headcount basis) in OECD members in 2008 and the Pupil-teacher ratio(headcount basis) in Brazil in 2009?
Your answer should be compact. -3.55. What is the difference between the Pupil-teacher ratio(headcount basis) of OECD members in 2008 and the Pupil-teacher ratio(headcount basis) of Panama in 2009?
Offer a very short reply. -1.07. What is the difference between the Pupil-teacher ratio(headcount basis) in Brazil in 2008 and the Pupil-teacher ratio(headcount basis) in Panama in 2009?
Your response must be concise. 2.54. What is the difference between the Pupil-teacher ratio(headcount basis) in North America in 2008 and the Pupil-teacher ratio(headcount basis) in OECD members in 2010?
Make the answer very short. 1.21. What is the difference between the Pupil-teacher ratio(headcount basis) of North America in 2008 and the Pupil-teacher ratio(headcount basis) of Brazil in 2010?
Give a very brief answer. -1.95. What is the difference between the Pupil-teacher ratio(headcount basis) in North America in 2008 and the Pupil-teacher ratio(headcount basis) in Panama in 2010?
Ensure brevity in your answer.  -0.63. What is the difference between the Pupil-teacher ratio(headcount basis) in OECD members in 2008 and the Pupil-teacher ratio(headcount basis) in Brazil in 2010?
Offer a very short reply. -3.07. What is the difference between the Pupil-teacher ratio(headcount basis) of OECD members in 2008 and the Pupil-teacher ratio(headcount basis) of Panama in 2010?
Offer a terse response. -1.75. What is the difference between the Pupil-teacher ratio(headcount basis) of Brazil in 2008 and the Pupil-teacher ratio(headcount basis) of Panama in 2010?
Offer a terse response. 1.86. What is the difference between the Pupil-teacher ratio(headcount basis) in North America in 2008 and the Pupil-teacher ratio(headcount basis) in OECD members in 2011?
Your response must be concise. 1.14. What is the difference between the Pupil-teacher ratio(headcount basis) of North America in 2008 and the Pupil-teacher ratio(headcount basis) of Brazil in 2011?
Your answer should be very brief. -1.64. What is the difference between the Pupil-teacher ratio(headcount basis) of North America in 2008 and the Pupil-teacher ratio(headcount basis) of Panama in 2011?
Provide a short and direct response. 0.02. What is the difference between the Pupil-teacher ratio(headcount basis) in OECD members in 2008 and the Pupil-teacher ratio(headcount basis) in Brazil in 2011?
Your answer should be very brief. -2.76. What is the difference between the Pupil-teacher ratio(headcount basis) in OECD members in 2008 and the Pupil-teacher ratio(headcount basis) in Panama in 2011?
Keep it short and to the point. -1.1. What is the difference between the Pupil-teacher ratio(headcount basis) of Brazil in 2008 and the Pupil-teacher ratio(headcount basis) of Panama in 2011?
Make the answer very short. 2.51. What is the difference between the Pupil-teacher ratio(headcount basis) in North America in 2009 and the Pupil-teacher ratio(headcount basis) in OECD members in 2010?
Offer a terse response. 0.82. What is the difference between the Pupil-teacher ratio(headcount basis) of North America in 2009 and the Pupil-teacher ratio(headcount basis) of Brazil in 2010?
Offer a very short reply. -2.35. What is the difference between the Pupil-teacher ratio(headcount basis) in North America in 2009 and the Pupil-teacher ratio(headcount basis) in Panama in 2010?
Offer a very short reply. -1.02. What is the difference between the Pupil-teacher ratio(headcount basis) of OECD members in 2009 and the Pupil-teacher ratio(headcount basis) of Brazil in 2010?
Provide a succinct answer. -3.16. What is the difference between the Pupil-teacher ratio(headcount basis) of OECD members in 2009 and the Pupil-teacher ratio(headcount basis) of Panama in 2010?
Give a very brief answer. -1.84. What is the difference between the Pupil-teacher ratio(headcount basis) in Brazil in 2009 and the Pupil-teacher ratio(headcount basis) in Panama in 2010?
Keep it short and to the point. 1.8. What is the difference between the Pupil-teacher ratio(headcount basis) of North America in 2009 and the Pupil-teacher ratio(headcount basis) of OECD members in 2011?
Keep it short and to the point. 0.75. What is the difference between the Pupil-teacher ratio(headcount basis) of North America in 2009 and the Pupil-teacher ratio(headcount basis) of Brazil in 2011?
Your answer should be compact. -2.03. What is the difference between the Pupil-teacher ratio(headcount basis) in North America in 2009 and the Pupil-teacher ratio(headcount basis) in Panama in 2011?
Give a very brief answer. -0.37. What is the difference between the Pupil-teacher ratio(headcount basis) in OECD members in 2009 and the Pupil-teacher ratio(headcount basis) in Brazil in 2011?
Your answer should be very brief. -2.85. What is the difference between the Pupil-teacher ratio(headcount basis) of OECD members in 2009 and the Pupil-teacher ratio(headcount basis) of Panama in 2011?
Make the answer very short. -1.18. What is the difference between the Pupil-teacher ratio(headcount basis) in Brazil in 2009 and the Pupil-teacher ratio(headcount basis) in Panama in 2011?
Give a very brief answer. 2.45. What is the difference between the Pupil-teacher ratio(headcount basis) in North America in 2010 and the Pupil-teacher ratio(headcount basis) in OECD members in 2011?
Keep it short and to the point. 0.56. What is the difference between the Pupil-teacher ratio(headcount basis) of North America in 2010 and the Pupil-teacher ratio(headcount basis) of Brazil in 2011?
Keep it short and to the point. -2.23. What is the difference between the Pupil-teacher ratio(headcount basis) in North America in 2010 and the Pupil-teacher ratio(headcount basis) in Panama in 2011?
Make the answer very short. -0.56. What is the difference between the Pupil-teacher ratio(headcount basis) in OECD members in 2010 and the Pupil-teacher ratio(headcount basis) in Brazil in 2011?
Provide a succinct answer. -2.85. What is the difference between the Pupil-teacher ratio(headcount basis) in OECD members in 2010 and the Pupil-teacher ratio(headcount basis) in Panama in 2011?
Give a very brief answer. -1.19. What is the difference between the Pupil-teacher ratio(headcount basis) of Brazil in 2010 and the Pupil-teacher ratio(headcount basis) of Panama in 2011?
Offer a terse response. 1.98. What is the average Pupil-teacher ratio(headcount basis) of North America per year?
Keep it short and to the point. 14.82. What is the average Pupil-teacher ratio(headcount basis) in OECD members per year?
Provide a short and direct response. 13.7. What is the average Pupil-teacher ratio(headcount basis) in Brazil per year?
Give a very brief answer. 17.06. What is the average Pupil-teacher ratio(headcount basis) of Panama per year?
Provide a short and direct response. 15.38. In the year 2002, what is the difference between the Pupil-teacher ratio(headcount basis) of North America and Pupil-teacher ratio(headcount basis) of OECD members?
Your answer should be very brief. 1.03. In the year 2002, what is the difference between the Pupil-teacher ratio(headcount basis) of North America and Pupil-teacher ratio(headcount basis) of Brazil?
Your response must be concise. -3.93. In the year 2002, what is the difference between the Pupil-teacher ratio(headcount basis) of North America and Pupil-teacher ratio(headcount basis) of Panama?
Ensure brevity in your answer.  -0.9. In the year 2002, what is the difference between the Pupil-teacher ratio(headcount basis) in OECD members and Pupil-teacher ratio(headcount basis) in Brazil?
Your answer should be compact. -4.96. In the year 2002, what is the difference between the Pupil-teacher ratio(headcount basis) of OECD members and Pupil-teacher ratio(headcount basis) of Panama?
Ensure brevity in your answer.  -1.93. In the year 2002, what is the difference between the Pupil-teacher ratio(headcount basis) in Brazil and Pupil-teacher ratio(headcount basis) in Panama?
Make the answer very short. 3.03. In the year 2004, what is the difference between the Pupil-teacher ratio(headcount basis) in North America and Pupil-teacher ratio(headcount basis) in OECD members?
Provide a short and direct response. 1.33. In the year 2004, what is the difference between the Pupil-teacher ratio(headcount basis) in North America and Pupil-teacher ratio(headcount basis) in Brazil?
Provide a succinct answer. -0.75. In the year 2004, what is the difference between the Pupil-teacher ratio(headcount basis) of North America and Pupil-teacher ratio(headcount basis) of Panama?
Keep it short and to the point. -0.49. In the year 2004, what is the difference between the Pupil-teacher ratio(headcount basis) of OECD members and Pupil-teacher ratio(headcount basis) of Brazil?
Give a very brief answer. -2.08. In the year 2004, what is the difference between the Pupil-teacher ratio(headcount basis) of OECD members and Pupil-teacher ratio(headcount basis) of Panama?
Your answer should be very brief. -1.82. In the year 2004, what is the difference between the Pupil-teacher ratio(headcount basis) in Brazil and Pupil-teacher ratio(headcount basis) in Panama?
Offer a terse response. 0.26. In the year 2005, what is the difference between the Pupil-teacher ratio(headcount basis) in North America and Pupil-teacher ratio(headcount basis) in OECD members?
Your answer should be very brief. 1.51. In the year 2005, what is the difference between the Pupil-teacher ratio(headcount basis) in North America and Pupil-teacher ratio(headcount basis) in Brazil?
Keep it short and to the point. -0.19. In the year 2005, what is the difference between the Pupil-teacher ratio(headcount basis) in North America and Pupil-teacher ratio(headcount basis) in Panama?
Give a very brief answer. -0.39. In the year 2005, what is the difference between the Pupil-teacher ratio(headcount basis) in OECD members and Pupil-teacher ratio(headcount basis) in Brazil?
Your answer should be very brief. -1.69. In the year 2005, what is the difference between the Pupil-teacher ratio(headcount basis) of OECD members and Pupil-teacher ratio(headcount basis) of Panama?
Provide a succinct answer. -1.9. In the year 2005, what is the difference between the Pupil-teacher ratio(headcount basis) in Brazil and Pupil-teacher ratio(headcount basis) in Panama?
Keep it short and to the point. -0.2. In the year 2007, what is the difference between the Pupil-teacher ratio(headcount basis) in North America and Pupil-teacher ratio(headcount basis) in OECD members?
Give a very brief answer. 1.29. In the year 2007, what is the difference between the Pupil-teacher ratio(headcount basis) in North America and Pupil-teacher ratio(headcount basis) in Brazil?
Your response must be concise. -3.67. In the year 2007, what is the difference between the Pupil-teacher ratio(headcount basis) of North America and Pupil-teacher ratio(headcount basis) of Panama?
Provide a succinct answer. -0.59. In the year 2007, what is the difference between the Pupil-teacher ratio(headcount basis) of OECD members and Pupil-teacher ratio(headcount basis) of Brazil?
Offer a terse response. -4.96. In the year 2007, what is the difference between the Pupil-teacher ratio(headcount basis) of OECD members and Pupil-teacher ratio(headcount basis) of Panama?
Provide a short and direct response. -1.88. In the year 2007, what is the difference between the Pupil-teacher ratio(headcount basis) of Brazil and Pupil-teacher ratio(headcount basis) of Panama?
Your answer should be very brief. 3.08. In the year 2008, what is the difference between the Pupil-teacher ratio(headcount basis) in North America and Pupil-teacher ratio(headcount basis) in OECD members?
Offer a very short reply. 1.12. In the year 2008, what is the difference between the Pupil-teacher ratio(headcount basis) of North America and Pupil-teacher ratio(headcount basis) of Brazil?
Offer a terse response. -2.49. In the year 2008, what is the difference between the Pupil-teacher ratio(headcount basis) of North America and Pupil-teacher ratio(headcount basis) of Panama?
Provide a short and direct response. -0.68. In the year 2008, what is the difference between the Pupil-teacher ratio(headcount basis) in OECD members and Pupil-teacher ratio(headcount basis) in Brazil?
Your response must be concise. -3.61. In the year 2008, what is the difference between the Pupil-teacher ratio(headcount basis) in OECD members and Pupil-teacher ratio(headcount basis) in Panama?
Provide a short and direct response. -1.8. In the year 2008, what is the difference between the Pupil-teacher ratio(headcount basis) in Brazil and Pupil-teacher ratio(headcount basis) in Panama?
Offer a very short reply. 1.81. In the year 2009, what is the difference between the Pupil-teacher ratio(headcount basis) in North America and Pupil-teacher ratio(headcount basis) in OECD members?
Provide a succinct answer. 0.81. In the year 2009, what is the difference between the Pupil-teacher ratio(headcount basis) of North America and Pupil-teacher ratio(headcount basis) of Brazil?
Make the answer very short. -2.82. In the year 2009, what is the difference between the Pupil-teacher ratio(headcount basis) of North America and Pupil-teacher ratio(headcount basis) of Panama?
Make the answer very short. -0.34. In the year 2009, what is the difference between the Pupil-teacher ratio(headcount basis) in OECD members and Pupil-teacher ratio(headcount basis) in Brazil?
Ensure brevity in your answer.  -3.64. In the year 2009, what is the difference between the Pupil-teacher ratio(headcount basis) in OECD members and Pupil-teacher ratio(headcount basis) in Panama?
Offer a very short reply. -1.15. In the year 2009, what is the difference between the Pupil-teacher ratio(headcount basis) in Brazil and Pupil-teacher ratio(headcount basis) in Panama?
Offer a very short reply. 2.48. In the year 2010, what is the difference between the Pupil-teacher ratio(headcount basis) in North America and Pupil-teacher ratio(headcount basis) in OECD members?
Your response must be concise. 0.63. In the year 2010, what is the difference between the Pupil-teacher ratio(headcount basis) of North America and Pupil-teacher ratio(headcount basis) of Brazil?
Provide a short and direct response. -2.54. In the year 2010, what is the difference between the Pupil-teacher ratio(headcount basis) in North America and Pupil-teacher ratio(headcount basis) in Panama?
Provide a succinct answer. -1.21. In the year 2010, what is the difference between the Pupil-teacher ratio(headcount basis) in OECD members and Pupil-teacher ratio(headcount basis) in Brazil?
Offer a terse response. -3.16. In the year 2010, what is the difference between the Pupil-teacher ratio(headcount basis) of OECD members and Pupil-teacher ratio(headcount basis) of Panama?
Offer a terse response. -1.84. In the year 2010, what is the difference between the Pupil-teacher ratio(headcount basis) in Brazil and Pupil-teacher ratio(headcount basis) in Panama?
Make the answer very short. 1.32. In the year 2011, what is the difference between the Pupil-teacher ratio(headcount basis) of North America and Pupil-teacher ratio(headcount basis) of OECD members?
Your answer should be very brief. 1.25. In the year 2011, what is the difference between the Pupil-teacher ratio(headcount basis) of North America and Pupil-teacher ratio(headcount basis) of Brazil?
Your response must be concise. -1.53. In the year 2011, what is the difference between the Pupil-teacher ratio(headcount basis) of North America and Pupil-teacher ratio(headcount basis) of Panama?
Offer a very short reply. 0.13. In the year 2011, what is the difference between the Pupil-teacher ratio(headcount basis) of OECD members and Pupil-teacher ratio(headcount basis) of Brazil?
Your answer should be very brief. -2.78. In the year 2011, what is the difference between the Pupil-teacher ratio(headcount basis) in OECD members and Pupil-teacher ratio(headcount basis) in Panama?
Your answer should be very brief. -1.12. In the year 2011, what is the difference between the Pupil-teacher ratio(headcount basis) in Brazil and Pupil-teacher ratio(headcount basis) in Panama?
Your answer should be very brief. 1.66. What is the ratio of the Pupil-teacher ratio(headcount basis) in OECD members in 2002 to that in 2004?
Give a very brief answer. 1.02. What is the ratio of the Pupil-teacher ratio(headcount basis) in Brazil in 2002 to that in 2004?
Provide a succinct answer. 1.19. What is the ratio of the Pupil-teacher ratio(headcount basis) in Panama in 2002 to that in 2004?
Provide a short and direct response. 1.02. What is the ratio of the Pupil-teacher ratio(headcount basis) in OECD members in 2002 to that in 2005?
Give a very brief answer. 1.03. What is the ratio of the Pupil-teacher ratio(headcount basis) in Brazil in 2002 to that in 2005?
Offer a terse response. 1.24. What is the ratio of the Pupil-teacher ratio(headcount basis) of Panama in 2002 to that in 2005?
Make the answer very short. 1.03. What is the ratio of the Pupil-teacher ratio(headcount basis) in North America in 2002 to that in 2007?
Offer a very short reply. 1.02. What is the ratio of the Pupil-teacher ratio(headcount basis) in OECD members in 2002 to that in 2007?
Make the answer very short. 1.04. What is the ratio of the Pupil-teacher ratio(headcount basis) in Brazil in 2002 to that in 2007?
Give a very brief answer. 1.03. What is the ratio of the Pupil-teacher ratio(headcount basis) in Panama in 2002 to that in 2007?
Offer a very short reply. 1.04. What is the ratio of the Pupil-teacher ratio(headcount basis) in North America in 2002 to that in 2008?
Offer a terse response. 1.03. What is the ratio of the Pupil-teacher ratio(headcount basis) of OECD members in 2002 to that in 2008?
Provide a short and direct response. 1.04. What is the ratio of the Pupil-teacher ratio(headcount basis) of Brazil in 2002 to that in 2008?
Ensure brevity in your answer.  1.11. What is the ratio of the Pupil-teacher ratio(headcount basis) of Panama in 2002 to that in 2008?
Your answer should be very brief. 1.05. What is the ratio of the Pupil-teacher ratio(headcount basis) in North America in 2002 to that in 2009?
Your answer should be very brief. 1.06. What is the ratio of the Pupil-teacher ratio(headcount basis) of OECD members in 2002 to that in 2009?
Give a very brief answer. 1.05. What is the ratio of the Pupil-teacher ratio(headcount basis) of Brazil in 2002 to that in 2009?
Offer a very short reply. 1.12. What is the ratio of the Pupil-teacher ratio(headcount basis) in Panama in 2002 to that in 2009?
Provide a succinct answer. 1.1. What is the ratio of the Pupil-teacher ratio(headcount basis) in North America in 2002 to that in 2010?
Your answer should be very brief. 1.08. What is the ratio of the Pupil-teacher ratio(headcount basis) in OECD members in 2002 to that in 2010?
Ensure brevity in your answer.  1.05. What is the ratio of the Pupil-teacher ratio(headcount basis) of Brazil in 2002 to that in 2010?
Your answer should be compact. 1.15. What is the ratio of the Pupil-teacher ratio(headcount basis) in Panama in 2002 to that in 2010?
Provide a short and direct response. 1.05. What is the ratio of the Pupil-teacher ratio(headcount basis) in North America in 2002 to that in 2011?
Provide a short and direct response. 1.03. What is the ratio of the Pupil-teacher ratio(headcount basis) in OECD members in 2002 to that in 2011?
Your answer should be very brief. 1.04. What is the ratio of the Pupil-teacher ratio(headcount basis) in Brazil in 2002 to that in 2011?
Your answer should be compact. 1.17. What is the ratio of the Pupil-teacher ratio(headcount basis) of Panama in 2002 to that in 2011?
Keep it short and to the point. 1.1. What is the ratio of the Pupil-teacher ratio(headcount basis) of OECD members in 2004 to that in 2005?
Keep it short and to the point. 1.01. What is the ratio of the Pupil-teacher ratio(headcount basis) of Brazil in 2004 to that in 2005?
Provide a succinct answer. 1.04. What is the ratio of the Pupil-teacher ratio(headcount basis) in Panama in 2004 to that in 2005?
Make the answer very short. 1.01. What is the ratio of the Pupil-teacher ratio(headcount basis) of North America in 2004 to that in 2007?
Give a very brief answer. 1.03. What is the ratio of the Pupil-teacher ratio(headcount basis) in OECD members in 2004 to that in 2007?
Your answer should be compact. 1.03. What is the ratio of the Pupil-teacher ratio(headcount basis) of Brazil in 2004 to that in 2007?
Your answer should be compact. 0.86. What is the ratio of the Pupil-teacher ratio(headcount basis) in Panama in 2004 to that in 2007?
Your answer should be compact. 1.02. What is the ratio of the Pupil-teacher ratio(headcount basis) in North America in 2004 to that in 2008?
Make the answer very short. 1.04. What is the ratio of the Pupil-teacher ratio(headcount basis) of OECD members in 2004 to that in 2008?
Your answer should be very brief. 1.03. What is the ratio of the Pupil-teacher ratio(headcount basis) in Brazil in 2004 to that in 2008?
Your answer should be compact. 0.93. What is the ratio of the Pupil-teacher ratio(headcount basis) of Panama in 2004 to that in 2008?
Keep it short and to the point. 1.02. What is the ratio of the Pupil-teacher ratio(headcount basis) of North America in 2004 to that in 2009?
Provide a succinct answer. 1.07. What is the ratio of the Pupil-teacher ratio(headcount basis) of OECD members in 2004 to that in 2009?
Ensure brevity in your answer.  1.03. What is the ratio of the Pupil-teacher ratio(headcount basis) in Brazil in 2004 to that in 2009?
Offer a very short reply. 0.93. What is the ratio of the Pupil-teacher ratio(headcount basis) of Panama in 2004 to that in 2009?
Keep it short and to the point. 1.08. What is the ratio of the Pupil-teacher ratio(headcount basis) in North America in 2004 to that in 2010?
Your response must be concise. 1.08. What is the ratio of the Pupil-teacher ratio(headcount basis) in OECD members in 2004 to that in 2010?
Make the answer very short. 1.03. What is the ratio of the Pupil-teacher ratio(headcount basis) in Brazil in 2004 to that in 2010?
Give a very brief answer. 0.96. What is the ratio of the Pupil-teacher ratio(headcount basis) of Panama in 2004 to that in 2010?
Your answer should be compact. 1.03. What is the ratio of the Pupil-teacher ratio(headcount basis) of North America in 2004 to that in 2011?
Ensure brevity in your answer.  1.03. What is the ratio of the Pupil-teacher ratio(headcount basis) of OECD members in 2004 to that in 2011?
Offer a terse response. 1.03. What is the ratio of the Pupil-teacher ratio(headcount basis) in Brazil in 2004 to that in 2011?
Offer a terse response. 0.98. What is the ratio of the Pupil-teacher ratio(headcount basis) of Panama in 2004 to that in 2011?
Your answer should be compact. 1.07. What is the ratio of the Pupil-teacher ratio(headcount basis) of North America in 2005 to that in 2007?
Your answer should be compact. 1.02. What is the ratio of the Pupil-teacher ratio(headcount basis) in OECD members in 2005 to that in 2007?
Your response must be concise. 1.01. What is the ratio of the Pupil-teacher ratio(headcount basis) of Brazil in 2005 to that in 2007?
Offer a very short reply. 0.83. What is the ratio of the Pupil-teacher ratio(headcount basis) of North America in 2005 to that in 2008?
Ensure brevity in your answer.  1.04. What is the ratio of the Pupil-teacher ratio(headcount basis) in OECD members in 2005 to that in 2008?
Provide a succinct answer. 1.01. What is the ratio of the Pupil-teacher ratio(headcount basis) of Brazil in 2005 to that in 2008?
Provide a short and direct response. 0.9. What is the ratio of the Pupil-teacher ratio(headcount basis) in Panama in 2005 to that in 2008?
Give a very brief answer. 1.02. What is the ratio of the Pupil-teacher ratio(headcount basis) of North America in 2005 to that in 2009?
Give a very brief answer. 1.06. What is the ratio of the Pupil-teacher ratio(headcount basis) of OECD members in 2005 to that in 2009?
Give a very brief answer. 1.02. What is the ratio of the Pupil-teacher ratio(headcount basis) of Brazil in 2005 to that in 2009?
Your response must be concise. 0.9. What is the ratio of the Pupil-teacher ratio(headcount basis) of Panama in 2005 to that in 2009?
Offer a very short reply. 1.07. What is the ratio of the Pupil-teacher ratio(headcount basis) of North America in 2005 to that in 2010?
Ensure brevity in your answer.  1.08. What is the ratio of the Pupil-teacher ratio(headcount basis) in OECD members in 2005 to that in 2010?
Provide a short and direct response. 1.02. What is the ratio of the Pupil-teacher ratio(headcount basis) in Brazil in 2005 to that in 2010?
Keep it short and to the point. 0.93. What is the ratio of the Pupil-teacher ratio(headcount basis) in North America in 2005 to that in 2011?
Provide a short and direct response. 1.03. What is the ratio of the Pupil-teacher ratio(headcount basis) in OECD members in 2005 to that in 2011?
Your response must be concise. 1.01. What is the ratio of the Pupil-teacher ratio(headcount basis) in Brazil in 2005 to that in 2011?
Your response must be concise. 0.94. What is the ratio of the Pupil-teacher ratio(headcount basis) of Panama in 2005 to that in 2011?
Offer a terse response. 1.06. What is the ratio of the Pupil-teacher ratio(headcount basis) of North America in 2007 to that in 2008?
Make the answer very short. 1.01. What is the ratio of the Pupil-teacher ratio(headcount basis) of Brazil in 2007 to that in 2008?
Your answer should be compact. 1.08. What is the ratio of the Pupil-teacher ratio(headcount basis) of Panama in 2007 to that in 2008?
Your answer should be compact. 1.01. What is the ratio of the Pupil-teacher ratio(headcount basis) in North America in 2007 to that in 2009?
Make the answer very short. 1.04. What is the ratio of the Pupil-teacher ratio(headcount basis) of OECD members in 2007 to that in 2009?
Your response must be concise. 1.01. What is the ratio of the Pupil-teacher ratio(headcount basis) of Brazil in 2007 to that in 2009?
Provide a succinct answer. 1.08. What is the ratio of the Pupil-teacher ratio(headcount basis) of Panama in 2007 to that in 2009?
Give a very brief answer. 1.06. What is the ratio of the Pupil-teacher ratio(headcount basis) in North America in 2007 to that in 2010?
Your response must be concise. 1.05. What is the ratio of the Pupil-teacher ratio(headcount basis) of OECD members in 2007 to that in 2010?
Your answer should be compact. 1.01. What is the ratio of the Pupil-teacher ratio(headcount basis) of Brazil in 2007 to that in 2010?
Provide a succinct answer. 1.11. What is the ratio of the Pupil-teacher ratio(headcount basis) in Panama in 2007 to that in 2010?
Offer a very short reply. 1.01. What is the ratio of the Pupil-teacher ratio(headcount basis) of OECD members in 2007 to that in 2011?
Give a very brief answer. 1. What is the ratio of the Pupil-teacher ratio(headcount basis) of Brazil in 2007 to that in 2011?
Give a very brief answer. 1.13. What is the ratio of the Pupil-teacher ratio(headcount basis) in Panama in 2007 to that in 2011?
Provide a short and direct response. 1.05. What is the ratio of the Pupil-teacher ratio(headcount basis) of North America in 2008 to that in 2009?
Ensure brevity in your answer.  1.03. What is the ratio of the Pupil-teacher ratio(headcount basis) in OECD members in 2008 to that in 2009?
Provide a succinct answer. 1.01. What is the ratio of the Pupil-teacher ratio(headcount basis) in Brazil in 2008 to that in 2009?
Keep it short and to the point. 1. What is the ratio of the Pupil-teacher ratio(headcount basis) in Panama in 2008 to that in 2009?
Give a very brief answer. 1.05. What is the ratio of the Pupil-teacher ratio(headcount basis) of North America in 2008 to that in 2010?
Provide a succinct answer. 1.04. What is the ratio of the Pupil-teacher ratio(headcount basis) of Brazil in 2008 to that in 2010?
Provide a short and direct response. 1.03. What is the ratio of the Pupil-teacher ratio(headcount basis) of North America in 2008 to that in 2011?
Make the answer very short. 0.99. What is the ratio of the Pupil-teacher ratio(headcount basis) in OECD members in 2008 to that in 2011?
Offer a very short reply. 1. What is the ratio of the Pupil-teacher ratio(headcount basis) of Brazil in 2008 to that in 2011?
Give a very brief answer. 1.05. What is the ratio of the Pupil-teacher ratio(headcount basis) of Panama in 2008 to that in 2011?
Provide a succinct answer. 1.05. What is the ratio of the Pupil-teacher ratio(headcount basis) of North America in 2009 to that in 2010?
Ensure brevity in your answer.  1.01. What is the ratio of the Pupil-teacher ratio(headcount basis) of OECD members in 2009 to that in 2010?
Offer a terse response. 1. What is the ratio of the Pupil-teacher ratio(headcount basis) of Brazil in 2009 to that in 2010?
Keep it short and to the point. 1.03. What is the ratio of the Pupil-teacher ratio(headcount basis) in Panama in 2009 to that in 2010?
Make the answer very short. 0.96. What is the ratio of the Pupil-teacher ratio(headcount basis) of North America in 2009 to that in 2011?
Keep it short and to the point. 0.97. What is the ratio of the Pupil-teacher ratio(headcount basis) of OECD members in 2009 to that in 2011?
Offer a very short reply. 1. What is the ratio of the Pupil-teacher ratio(headcount basis) of Brazil in 2009 to that in 2011?
Provide a short and direct response. 1.05. What is the ratio of the Pupil-teacher ratio(headcount basis) of North America in 2010 to that in 2011?
Make the answer very short. 0.95. What is the ratio of the Pupil-teacher ratio(headcount basis) of OECD members in 2010 to that in 2011?
Your answer should be very brief. 0.99. What is the ratio of the Pupil-teacher ratio(headcount basis) of Brazil in 2010 to that in 2011?
Provide a succinct answer. 1.02. What is the ratio of the Pupil-teacher ratio(headcount basis) in Panama in 2010 to that in 2011?
Offer a terse response. 1.04. What is the difference between the highest and the second highest Pupil-teacher ratio(headcount basis) of North America?
Provide a succinct answer. 0.03. What is the difference between the highest and the second highest Pupil-teacher ratio(headcount basis) of OECD members?
Your response must be concise. 0.22. What is the difference between the highest and the second highest Pupil-teacher ratio(headcount basis) in Brazil?
Your answer should be very brief. 0.57. What is the difference between the highest and the second highest Pupil-teacher ratio(headcount basis) of Panama?
Provide a short and direct response. 0.33. What is the difference between the highest and the lowest Pupil-teacher ratio(headcount basis) of North America?
Your answer should be compact. 1.15. What is the difference between the highest and the lowest Pupil-teacher ratio(headcount basis) in OECD members?
Give a very brief answer. 0.66. What is the difference between the highest and the lowest Pupil-teacher ratio(headcount basis) in Brazil?
Give a very brief answer. 3.69. What is the difference between the highest and the lowest Pupil-teacher ratio(headcount basis) in Panama?
Provide a short and direct response. 1.43. 